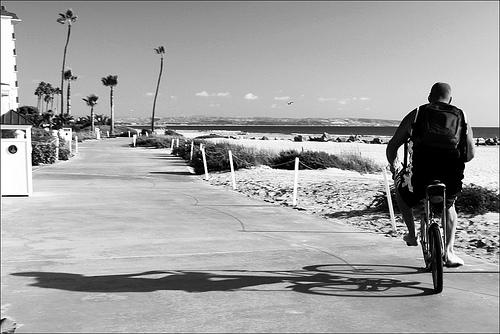Who is riding the bike?
Quick response, please. Man. Who is skiing?
Answer briefly. No one. Is this man wearing a ponytail?
Short answer required. No. How many bikes are there?
Be succinct. 1. What type of trees are the tall ones?
Quick response, please. Palm. Is it summer time?
Give a very brief answer. Yes. Is someone walking on the sidewalk?
Concise answer only. No. How many bikes are pictured?
Answer briefly. 1. What are the people doing?
Short answer required. Biking. What color are the bins?
Quick response, please. White. Is the way the man is riding the bike difficult?
Keep it brief. No. How many people are riding bikes?
Quick response, please. 1. What are they riding on?
Answer briefly. Bike. Why is the ground white?
Concise answer only. Sand. What is the man doing?
Keep it brief. Riding bike. Where is the man riding his bike?
Be succinct. Beach. Is it Winter time?
Be succinct. No. Is there a stop sign?
Concise answer only. No. How many bikers are  there?
Quick response, please. 1. 